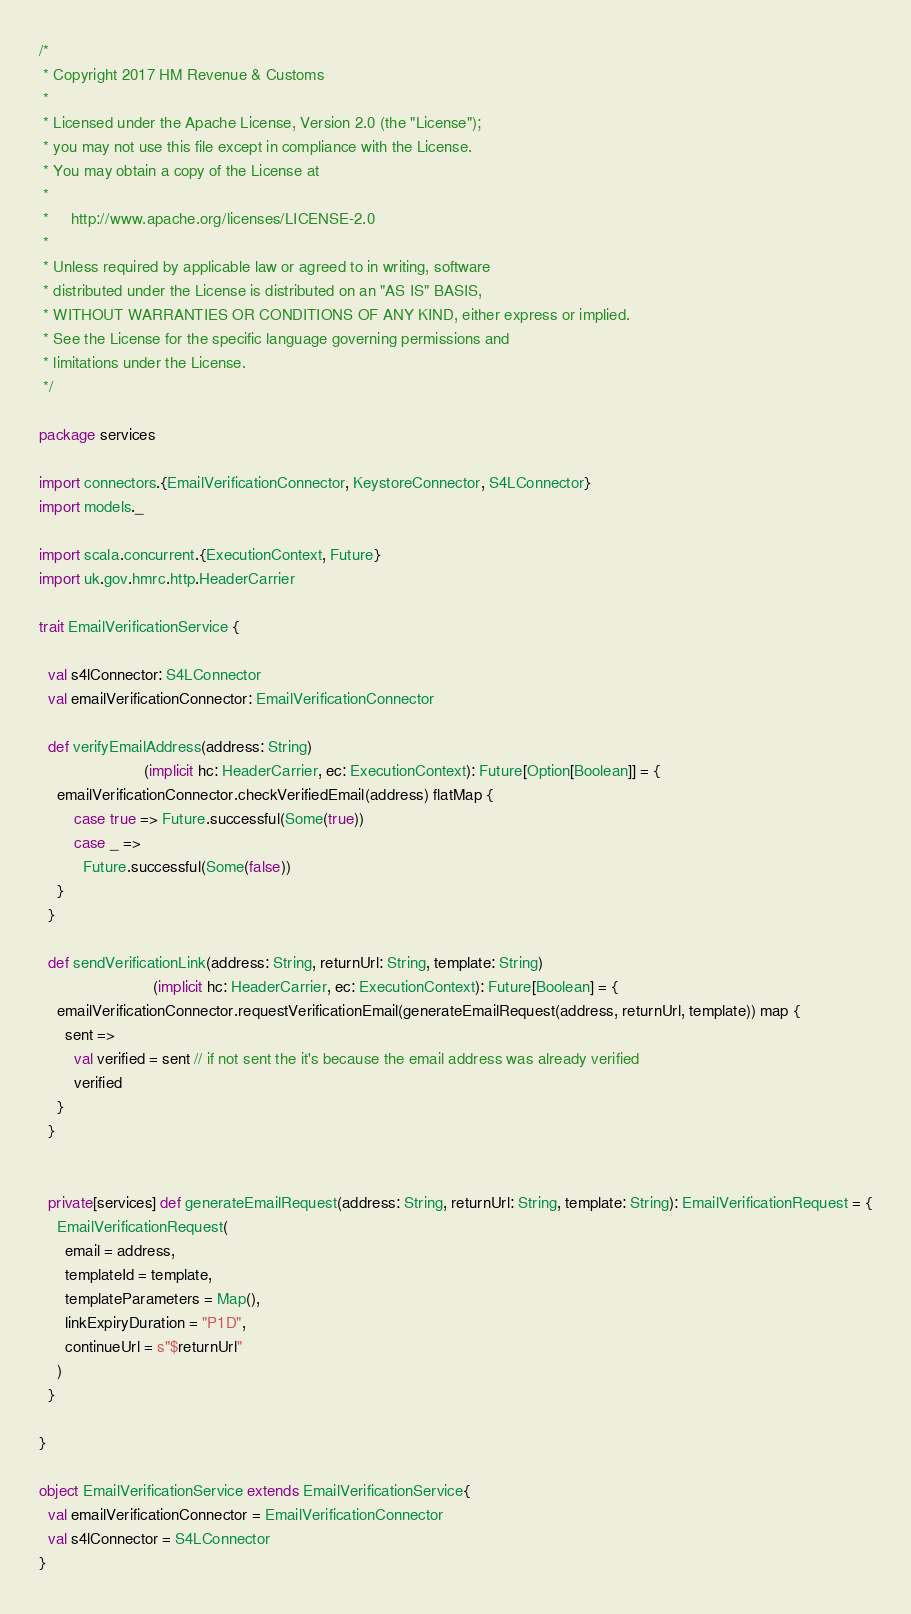Convert code to text. <code><loc_0><loc_0><loc_500><loc_500><_Scala_>/*
 * Copyright 2017 HM Revenue & Customs
 *
 * Licensed under the Apache License, Version 2.0 (the "License");
 * you may not use this file except in compliance with the License.
 * You may obtain a copy of the License at
 *
 *     http://www.apache.org/licenses/LICENSE-2.0
 *
 * Unless required by applicable law or agreed to in writing, software
 * distributed under the License is distributed on an "AS IS" BASIS,
 * WITHOUT WARRANTIES OR CONDITIONS OF ANY KIND, either express or implied.
 * See the License for the specific language governing permissions and
 * limitations under the License.
 */

package services

import connectors.{EmailVerificationConnector, KeystoreConnector, S4LConnector}
import models._

import scala.concurrent.{ExecutionContext, Future}
import uk.gov.hmrc.http.HeaderCarrier

trait EmailVerificationService {

  val s4lConnector: S4LConnector
  val emailVerificationConnector: EmailVerificationConnector

  def verifyEmailAddress(address: String)
                        (implicit hc: HeaderCarrier, ec: ExecutionContext): Future[Option[Boolean]] = {
    emailVerificationConnector.checkVerifiedEmail(address) flatMap {
        case true => Future.successful(Some(true))
        case _ =>
          Future.successful(Some(false))
    }
  }

  def sendVerificationLink(address: String, returnUrl: String, template: String)
                          (implicit hc: HeaderCarrier, ec: ExecutionContext): Future[Boolean] = {
    emailVerificationConnector.requestVerificationEmail(generateEmailRequest(address, returnUrl, template)) map {
      sent =>
        val verified = sent // if not sent the it's because the email address was already verified
        verified
    }
  }


  private[services] def generateEmailRequest(address: String, returnUrl: String, template: String): EmailVerificationRequest = {
    EmailVerificationRequest(
      email = address,
      templateId = template,
      templateParameters = Map(),
      linkExpiryDuration = "P1D",
      continueUrl = s"$returnUrl"
    )
  }

}

object EmailVerificationService extends EmailVerificationService{
  val emailVerificationConnector = EmailVerificationConnector
  val s4lConnector = S4LConnector
}
</code> 